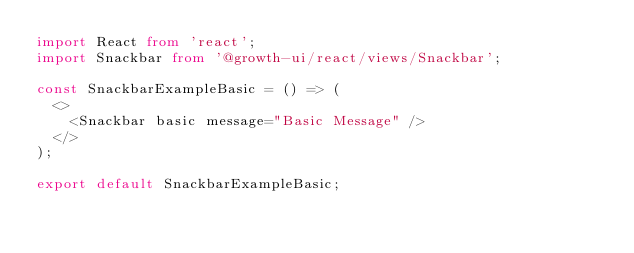Convert code to text. <code><loc_0><loc_0><loc_500><loc_500><_TypeScript_>import React from 'react';
import Snackbar from '@growth-ui/react/views/Snackbar';

const SnackbarExampleBasic = () => (
  <>
    <Snackbar basic message="Basic Message" />
  </>
);

export default SnackbarExampleBasic;
</code> 